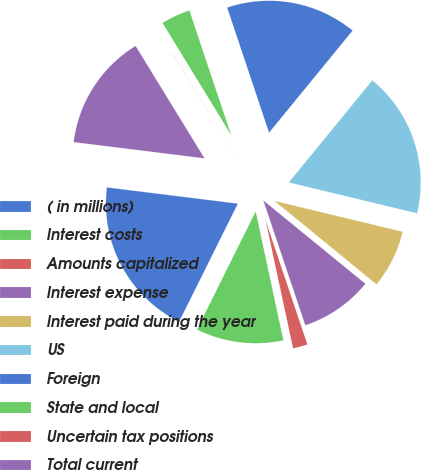Convert chart to OTSL. <chart><loc_0><loc_0><loc_500><loc_500><pie_chart><fcel>( in millions)<fcel>Interest costs<fcel>Amounts capitalized<fcel>Interest expense<fcel>Interest paid during the year<fcel>US<fcel>Foreign<fcel>State and local<fcel>Uncertain tax positions<fcel>Total current<nl><fcel>19.62%<fcel>10.71%<fcel>1.8%<fcel>8.93%<fcel>7.15%<fcel>17.84%<fcel>16.06%<fcel>3.59%<fcel>0.02%<fcel>14.28%<nl></chart> 